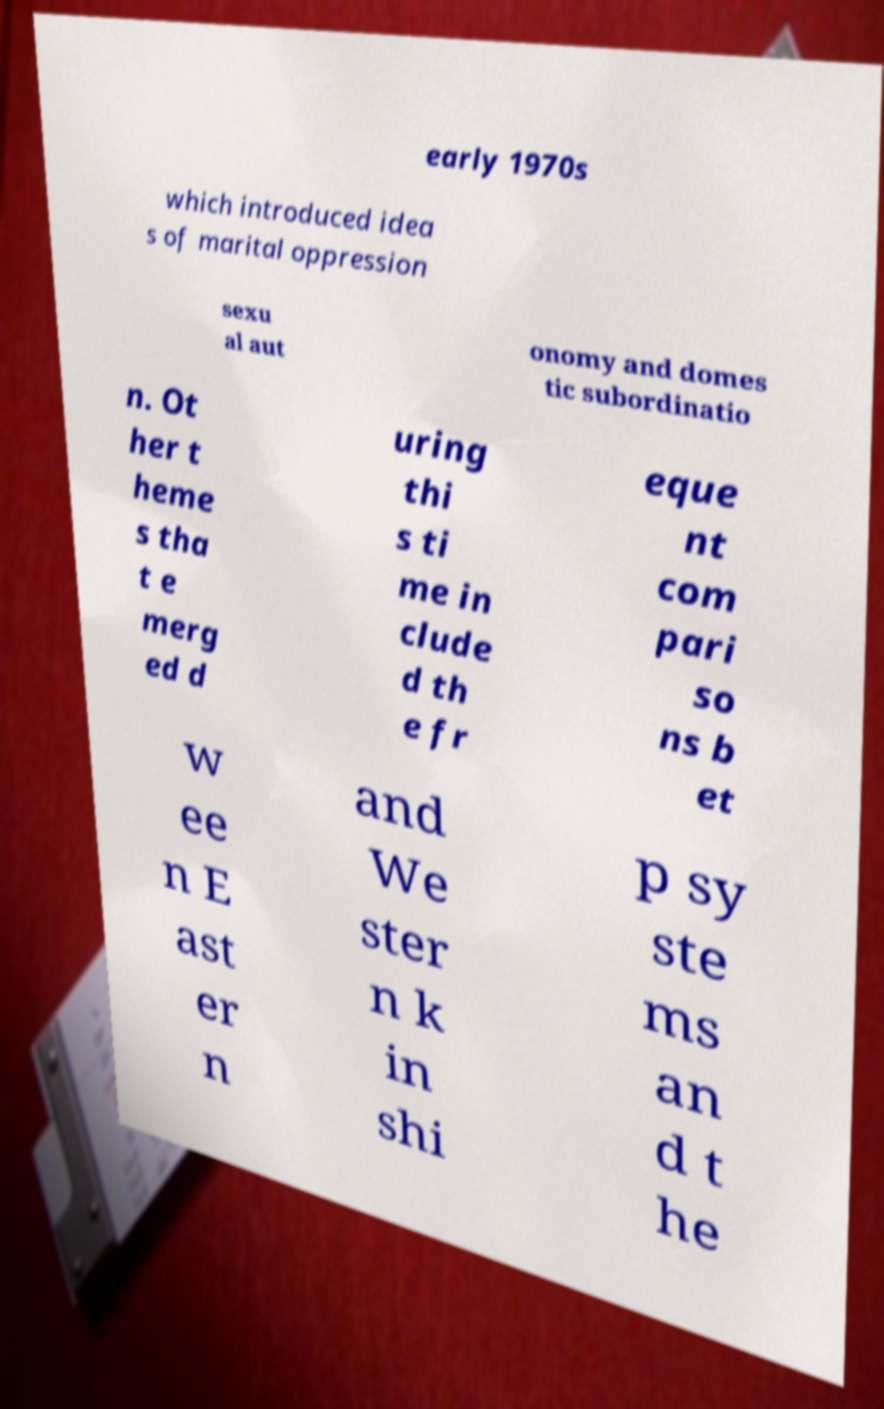What messages or text are displayed in this image? I need them in a readable, typed format. early 1970s which introduced idea s of marital oppression sexu al aut onomy and domes tic subordinatio n. Ot her t heme s tha t e merg ed d uring thi s ti me in clude d th e fr eque nt com pari so ns b et w ee n E ast er n and We ster n k in shi p sy ste ms an d t he 